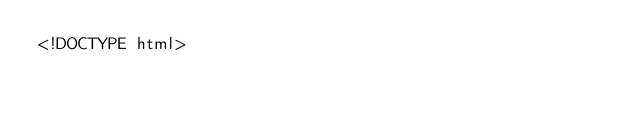<code> <loc_0><loc_0><loc_500><loc_500><_HTML_><!DOCTYPE html></code> 